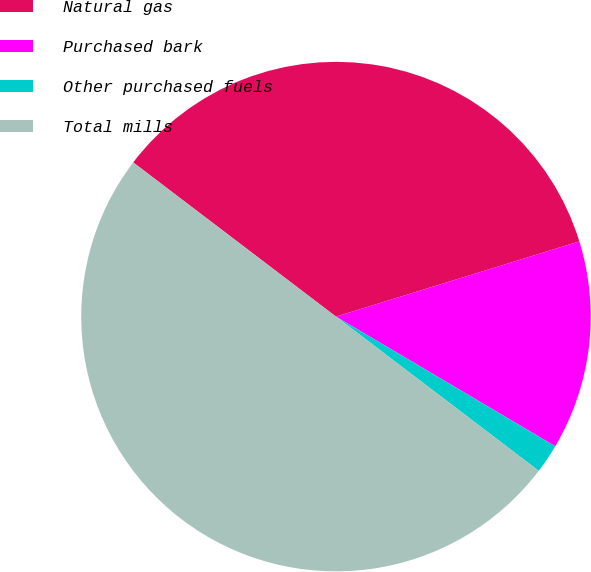Convert chart. <chart><loc_0><loc_0><loc_500><loc_500><pie_chart><fcel>Natural gas<fcel>Purchased bark<fcel>Other purchased fuels<fcel>Total mills<nl><fcel>34.88%<fcel>13.27%<fcel>1.85%<fcel>50.0%<nl></chart> 